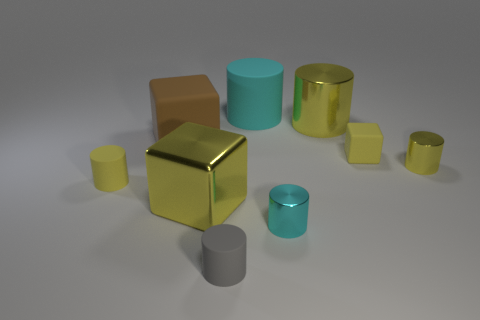There is a cylinder that is behind the tiny yellow rubber cube and in front of the cyan matte cylinder; what is its size?
Keep it short and to the point. Large. Is the number of small gray rubber cylinders that are right of the large rubber cylinder less than the number of yellow spheres?
Offer a very short reply. No. Are the small gray cylinder and the tiny cyan object made of the same material?
Your answer should be very brief. No. How many objects are either tiny blue cylinders or yellow cylinders?
Your answer should be compact. 3. What number of blocks have the same material as the big cyan cylinder?
Offer a very short reply. 2. There is a gray rubber thing that is the same shape as the big cyan object; what is its size?
Your answer should be compact. Small. Are there any gray cylinders on the right side of the tiny yellow shiny cylinder?
Your answer should be very brief. No. What is the small cube made of?
Your response must be concise. Rubber. There is a small cylinder to the left of the brown cube; is its color the same as the tiny rubber cube?
Make the answer very short. Yes. Are there any other things that have the same shape as the small cyan object?
Provide a succinct answer. Yes. 